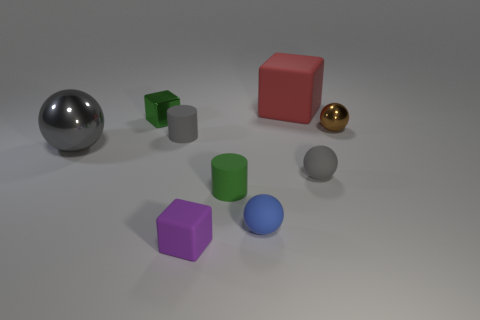The matte cylinder that is the same color as the large shiny object is what size?
Your response must be concise. Small. There is a rubber cylinder that is behind the small gray rubber thing on the right side of the small purple thing; how many tiny things are behind it?
Keep it short and to the point. 2. Are there any big matte objects that have the same color as the tiny matte block?
Provide a short and direct response. No. There is a metal block that is the same size as the brown ball; what is its color?
Make the answer very short. Green. The tiny gray matte thing right of the matte object in front of the blue matte object in front of the brown thing is what shape?
Keep it short and to the point. Sphere. There is a large thing on the left side of the small blue rubber ball; what number of small gray rubber things are in front of it?
Provide a succinct answer. 1. Does the tiny gray thing that is to the left of the big block have the same shape as the big object that is on the right side of the blue sphere?
Provide a succinct answer. No. How many metallic spheres are in front of the small gray cylinder?
Provide a short and direct response. 1. Do the gray sphere left of the large cube and the brown object have the same material?
Offer a terse response. Yes. What color is the other small shiny object that is the same shape as the gray metal object?
Your response must be concise. Brown. 